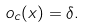Convert formula to latex. <formula><loc_0><loc_0><loc_500><loc_500>o _ { c } ( x ) = \delta .</formula> 